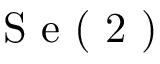<formula> <loc_0><loc_0><loc_500><loc_500>S e ( 2 )</formula> 